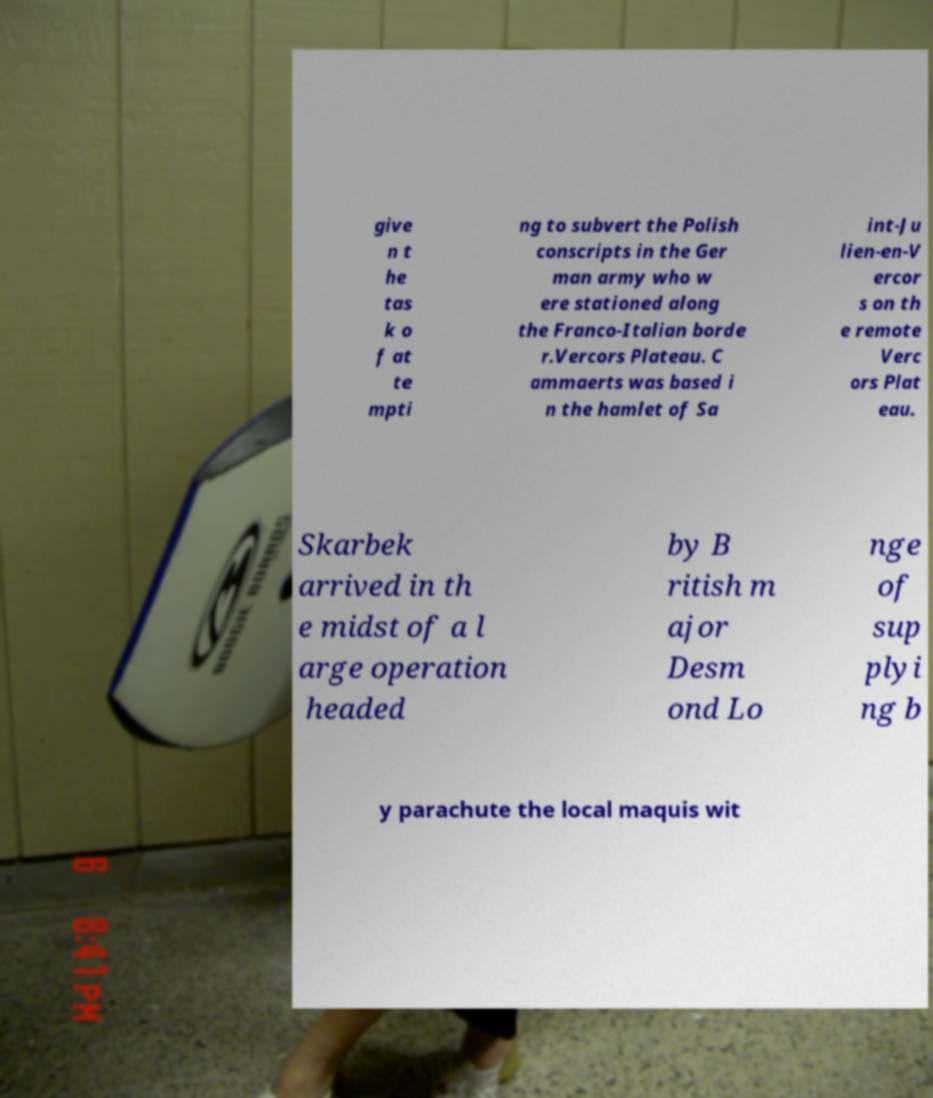There's text embedded in this image that I need extracted. Can you transcribe it verbatim? give n t he tas k o f at te mpti ng to subvert the Polish conscripts in the Ger man army who w ere stationed along the Franco-Italian borde r.Vercors Plateau. C ammaerts was based i n the hamlet of Sa int-Ju lien-en-V ercor s on th e remote Verc ors Plat eau. Skarbek arrived in th e midst of a l arge operation headed by B ritish m ajor Desm ond Lo nge of sup plyi ng b y parachute the local maquis wit 